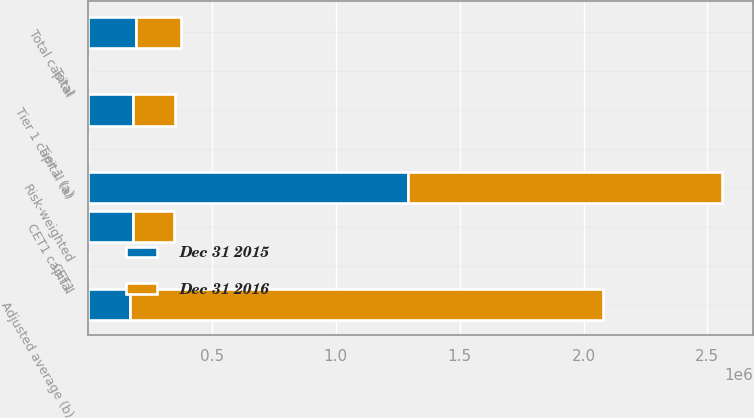Convert chart to OTSL. <chart><loc_0><loc_0><loc_500><loc_500><stacked_bar_chart><ecel><fcel>CET1 capital<fcel>Tier 1 capital (a)<fcel>Total capital<fcel>Risk-weighted<fcel>Adjusted average (b)<fcel>CET1<fcel>Tier 1 (a)<fcel>Total<nl><fcel>Dec 31 2015<fcel>179319<fcel>179341<fcel>191662<fcel>1.2932e+06<fcel>169222<fcel>13.9<fcel>13.9<fcel>14.8<nl><fcel>Dec 31 2016<fcel>168857<fcel>169222<fcel>183262<fcel>1.26406e+06<fcel>1.91093e+06<fcel>13.4<fcel>13.4<fcel>14.5<nl></chart> 